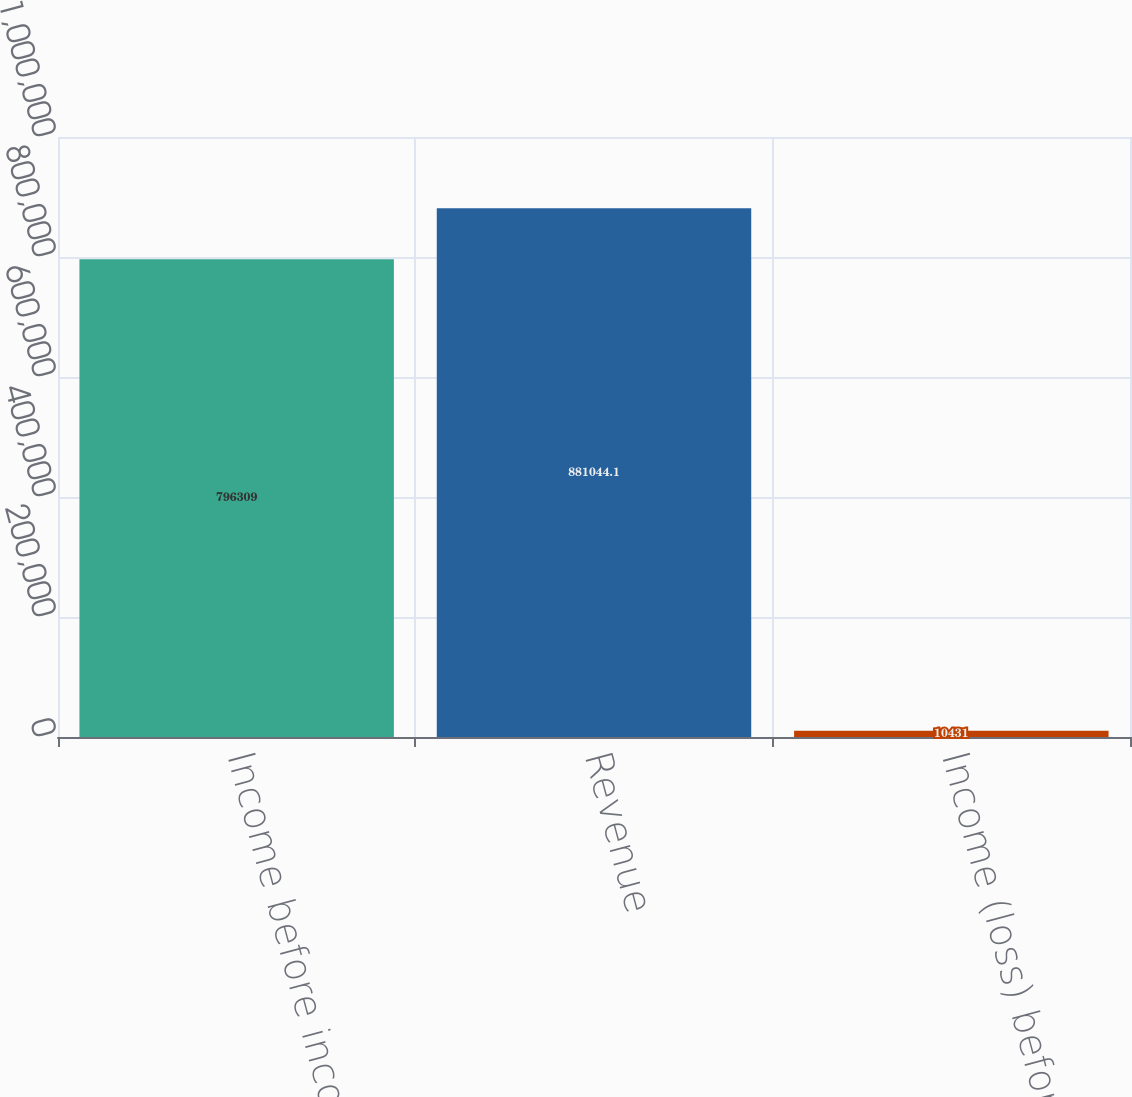<chart> <loc_0><loc_0><loc_500><loc_500><bar_chart><fcel>Income before income taxes<fcel>Revenue<fcel>Income (loss) before income<nl><fcel>796309<fcel>881044<fcel>10431<nl></chart> 